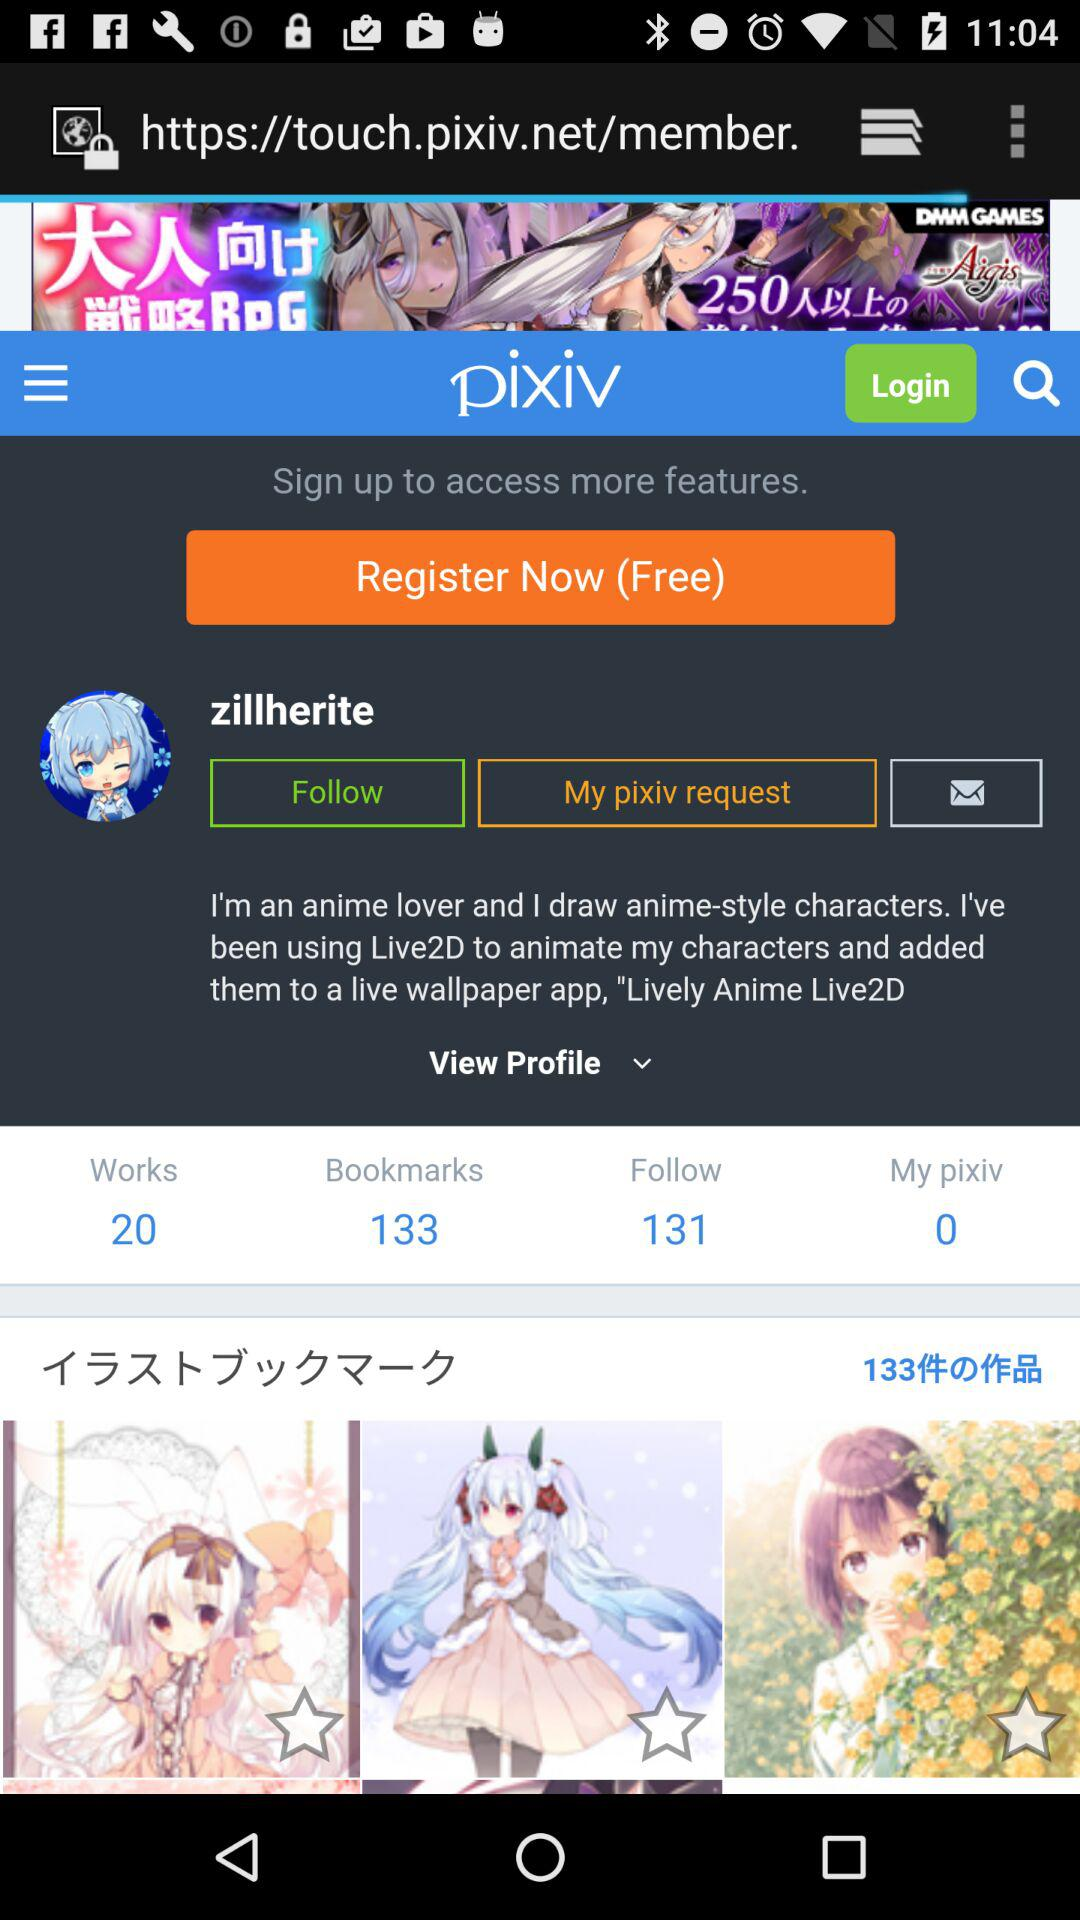How much is the work? The work is 20. 